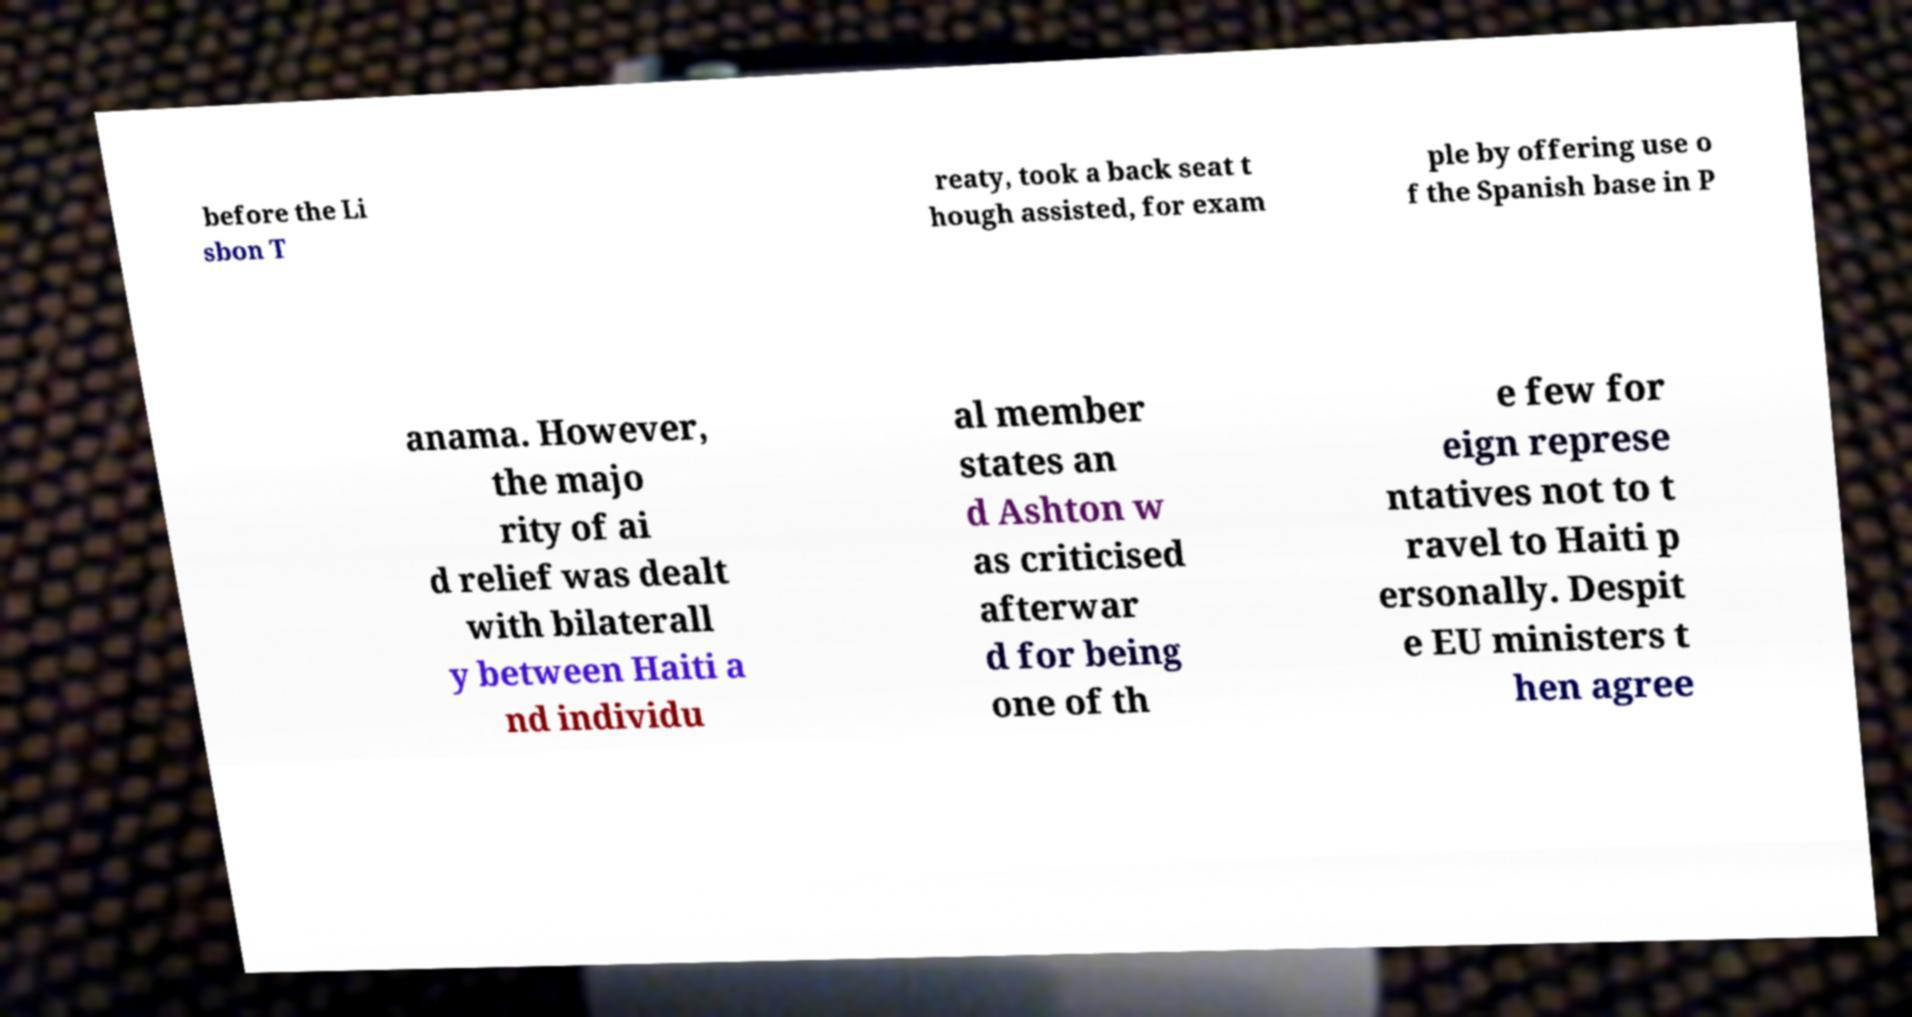There's text embedded in this image that I need extracted. Can you transcribe it verbatim? before the Li sbon T reaty, took a back seat t hough assisted, for exam ple by offering use o f the Spanish base in P anama. However, the majo rity of ai d relief was dealt with bilaterall y between Haiti a nd individu al member states an d Ashton w as criticised afterwar d for being one of th e few for eign represe ntatives not to t ravel to Haiti p ersonally. Despit e EU ministers t hen agree 